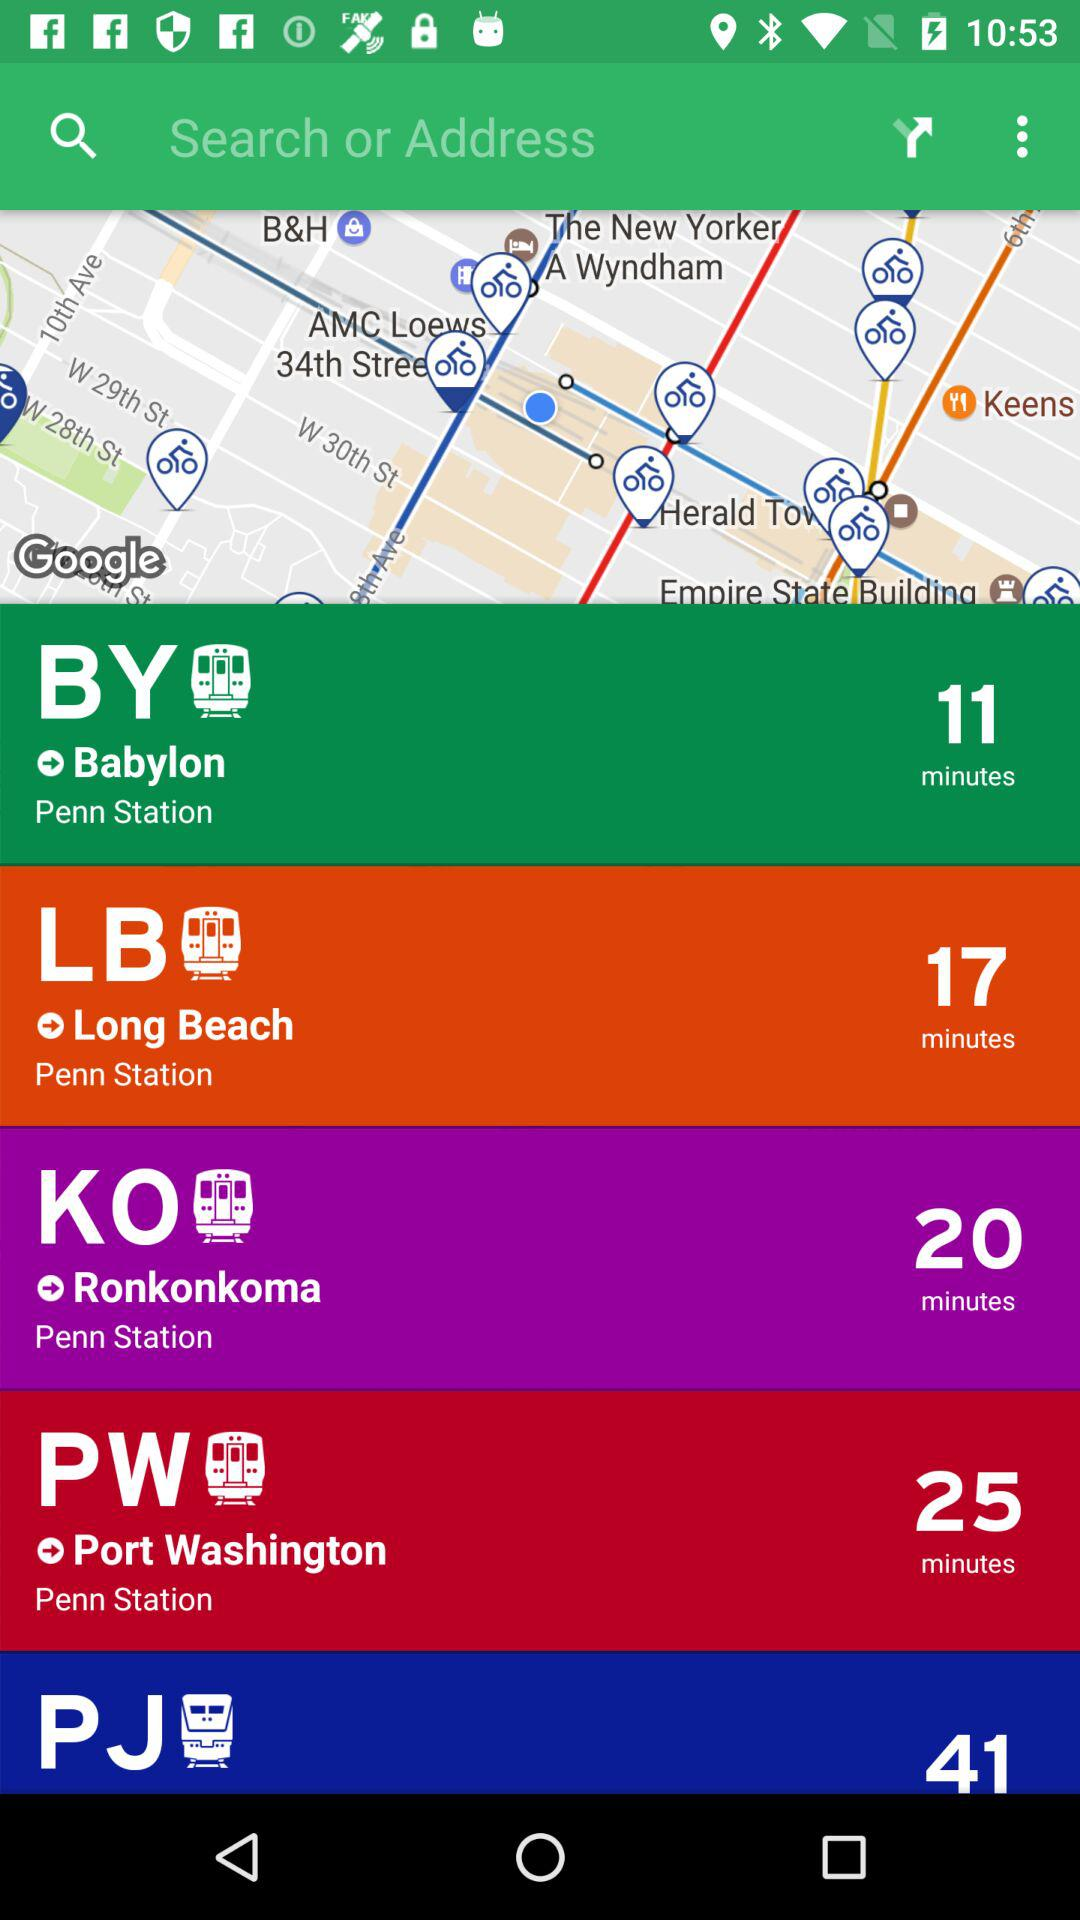Between which stations is the journey time 20 minutes? The journey time is 20 minutes between "Penn Station" and "Ronkonkoma". 